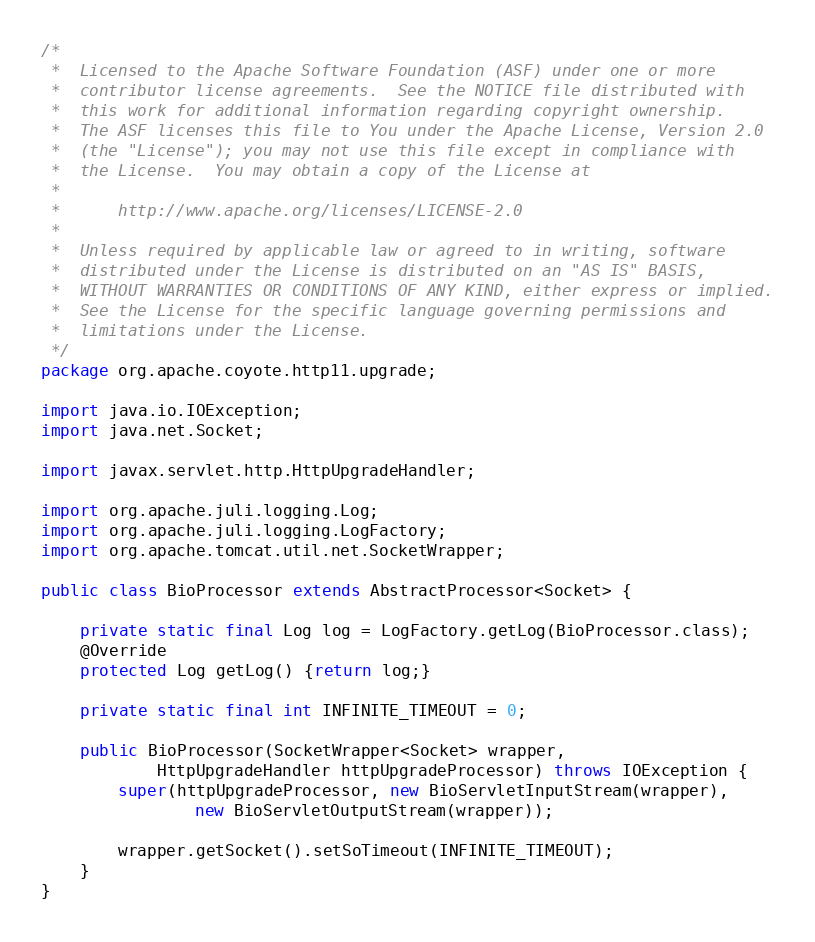<code> <loc_0><loc_0><loc_500><loc_500><_Java_>/*
 *  Licensed to the Apache Software Foundation (ASF) under one or more
 *  contributor license agreements.  See the NOTICE file distributed with
 *  this work for additional information regarding copyright ownership.
 *  The ASF licenses this file to You under the Apache License, Version 2.0
 *  (the "License"); you may not use this file except in compliance with
 *  the License.  You may obtain a copy of the License at
 *
 *      http://www.apache.org/licenses/LICENSE-2.0
 *
 *  Unless required by applicable law or agreed to in writing, software
 *  distributed under the License is distributed on an "AS IS" BASIS,
 *  WITHOUT WARRANTIES OR CONDITIONS OF ANY KIND, either express or implied.
 *  See the License for the specific language governing permissions and
 *  limitations under the License.
 */
package org.apache.coyote.http11.upgrade;

import java.io.IOException;
import java.net.Socket;

import javax.servlet.http.HttpUpgradeHandler;

import org.apache.juli.logging.Log;
import org.apache.juli.logging.LogFactory;
import org.apache.tomcat.util.net.SocketWrapper;

public class BioProcessor extends AbstractProcessor<Socket> {

    private static final Log log = LogFactory.getLog(BioProcessor.class);
    @Override
    protected Log getLog() {return log;}

    private static final int INFINITE_TIMEOUT = 0;

    public BioProcessor(SocketWrapper<Socket> wrapper,
            HttpUpgradeHandler httpUpgradeProcessor) throws IOException {
        super(httpUpgradeProcessor, new BioServletInputStream(wrapper),
                new BioServletOutputStream(wrapper));

        wrapper.getSocket().setSoTimeout(INFINITE_TIMEOUT);
    }
}
</code> 